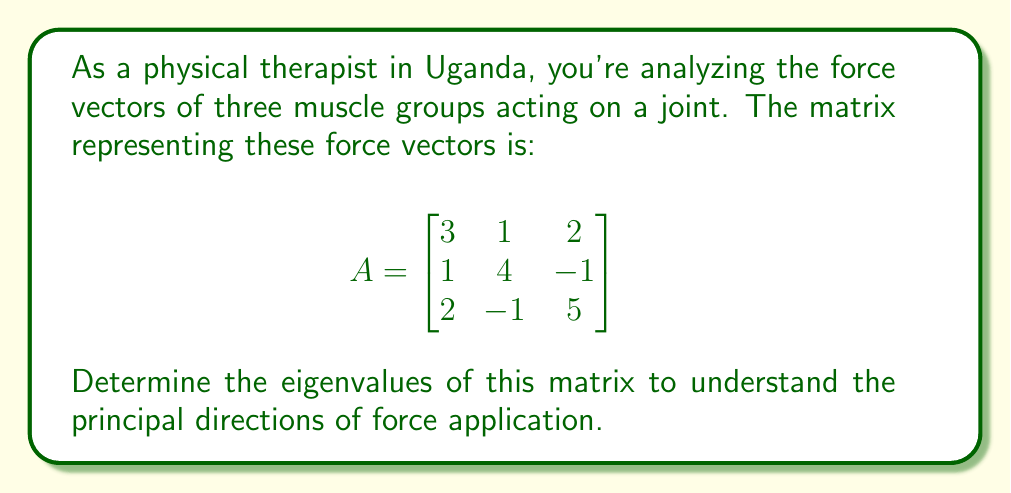Show me your answer to this math problem. To find the eigenvalues of matrix A, we follow these steps:

1) The eigenvalues λ are solutions to the characteristic equation:
   $\det(A - λI) = 0$, where I is the 3x3 identity matrix.

2) Expand the determinant:
   $$\det\begin{pmatrix}
   3-λ & 1 & 2 \\
   1 & 4-λ & -1 \\
   2 & -1 & 5-λ
   \end{pmatrix} = 0$$

3) Calculate the determinant:
   $(3-λ)[(4-λ)(5-λ) + 1] - 1[1(5-λ) - 2(-1)] + 2[1(-1) - (4-λ)(2)] = 0$

4) Simplify:
   $(3-λ)(20-9λ+λ^2) - (5-λ+2) + 2(-1-8+2λ) = 0$
   $60-27λ+3λ^2-20λ+9λ^2-λ^3 - 7+λ - 2+16-4λ = 0$

5) Collect terms:
   $-λ^3 + 12λ^2 - 30λ + 67 = 0$

6) This is a cubic equation. We can solve it using the rational root theorem or a computer algebra system.

7) The solutions to this equation are the eigenvalues:
   $λ_1 = 7$, $λ_2 = 3$, $λ_3 = 2$

These eigenvalues represent the magnitudes of the principal force directions in the joint system.
Answer: $λ_1 = 7$, $λ_2 = 3$, $λ_3 = 2$ 